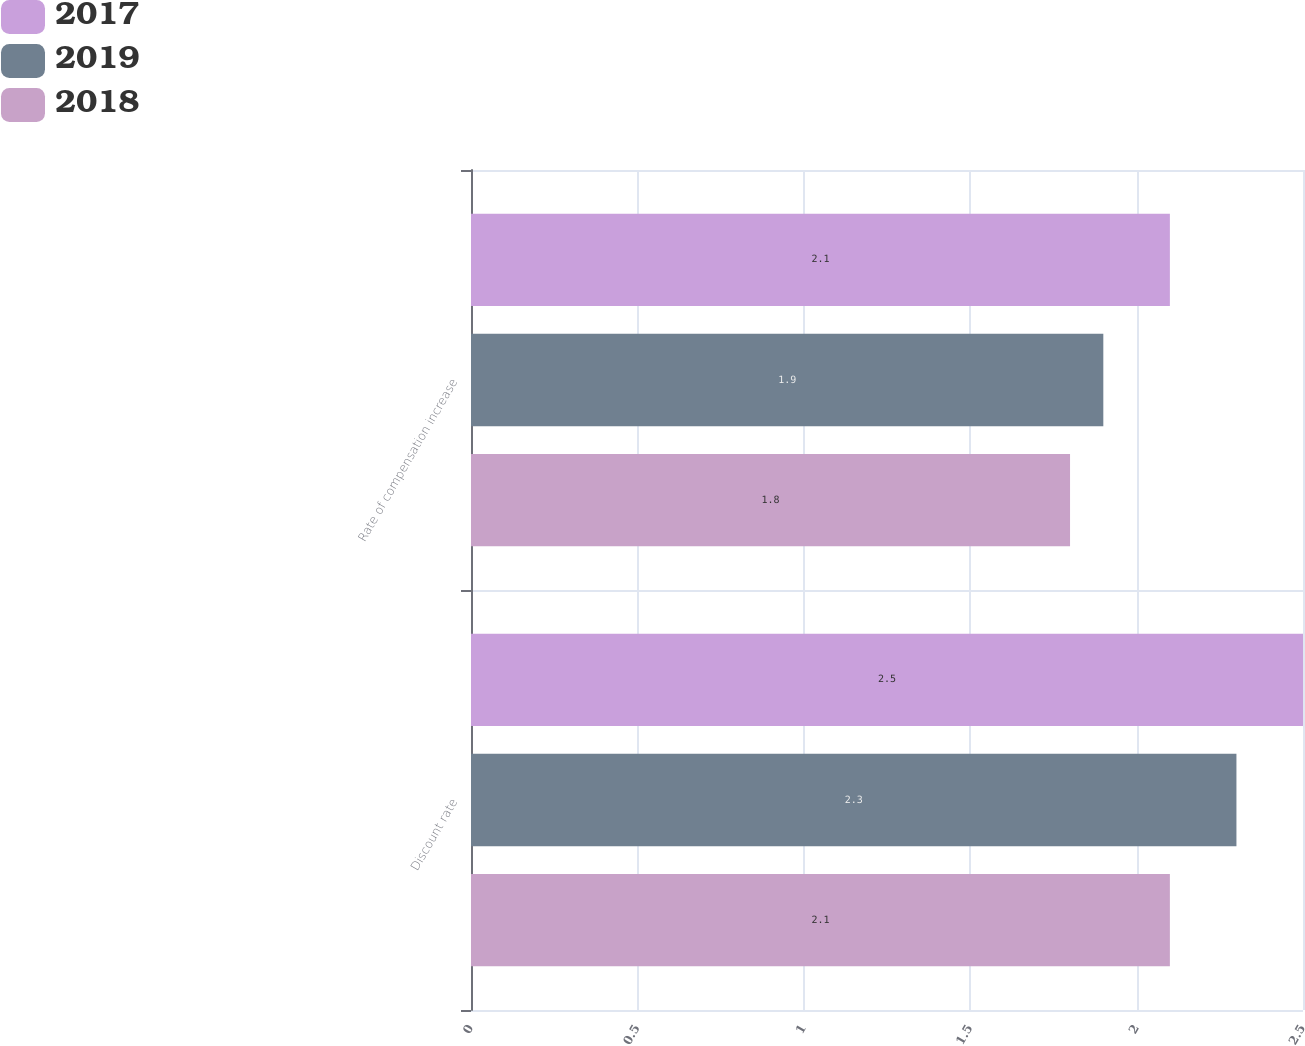<chart> <loc_0><loc_0><loc_500><loc_500><stacked_bar_chart><ecel><fcel>Discount rate<fcel>Rate of compensation increase<nl><fcel>2017<fcel>2.5<fcel>2.1<nl><fcel>2019<fcel>2.3<fcel>1.9<nl><fcel>2018<fcel>2.1<fcel>1.8<nl></chart> 